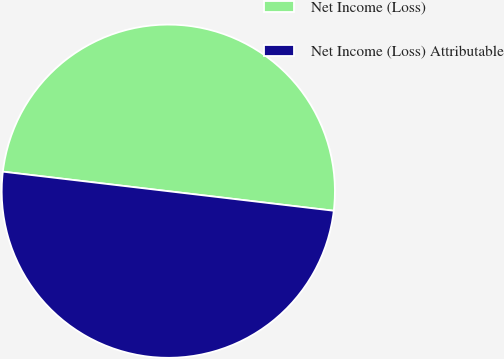<chart> <loc_0><loc_0><loc_500><loc_500><pie_chart><fcel>Net Income (Loss)<fcel>Net Income (Loss) Attributable<nl><fcel>50.0%<fcel>50.0%<nl></chart> 